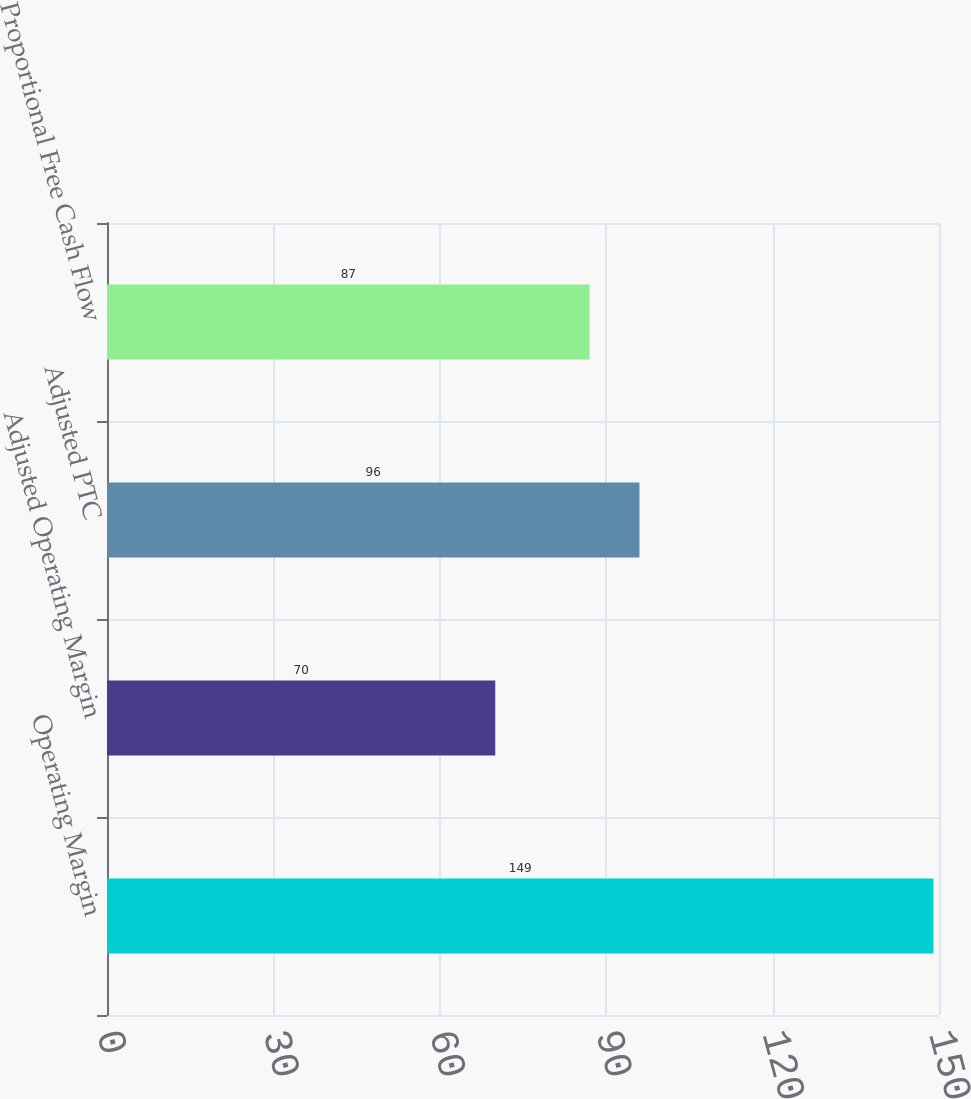Convert chart to OTSL. <chart><loc_0><loc_0><loc_500><loc_500><bar_chart><fcel>Operating Margin<fcel>Adjusted Operating Margin<fcel>Adjusted PTC<fcel>Proportional Free Cash Flow<nl><fcel>149<fcel>70<fcel>96<fcel>87<nl></chart> 